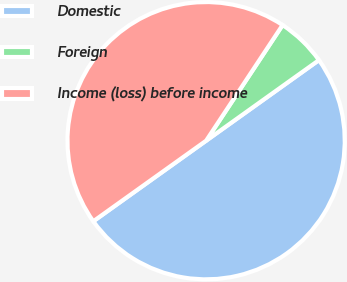Convert chart. <chart><loc_0><loc_0><loc_500><loc_500><pie_chart><fcel>Domestic<fcel>Foreign<fcel>Income (loss) before income<nl><fcel>50.0%<fcel>5.83%<fcel>44.17%<nl></chart> 